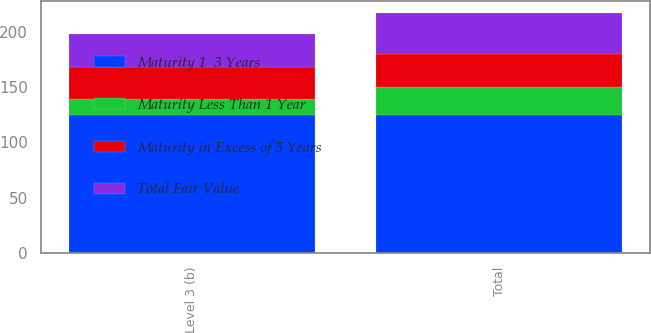Convert chart. <chart><loc_0><loc_0><loc_500><loc_500><stacked_bar_chart><ecel><fcel>Level 3 (b)<fcel>Total<nl><fcel>Maturity Less Than 1 Year<fcel>14<fcel>25<nl><fcel>Total Fair Value<fcel>30<fcel>37<nl><fcel>Maturity in Excess of 5 Years<fcel>29<fcel>30<nl><fcel>Maturity 1  3 Years<fcel>125<fcel>125<nl></chart> 